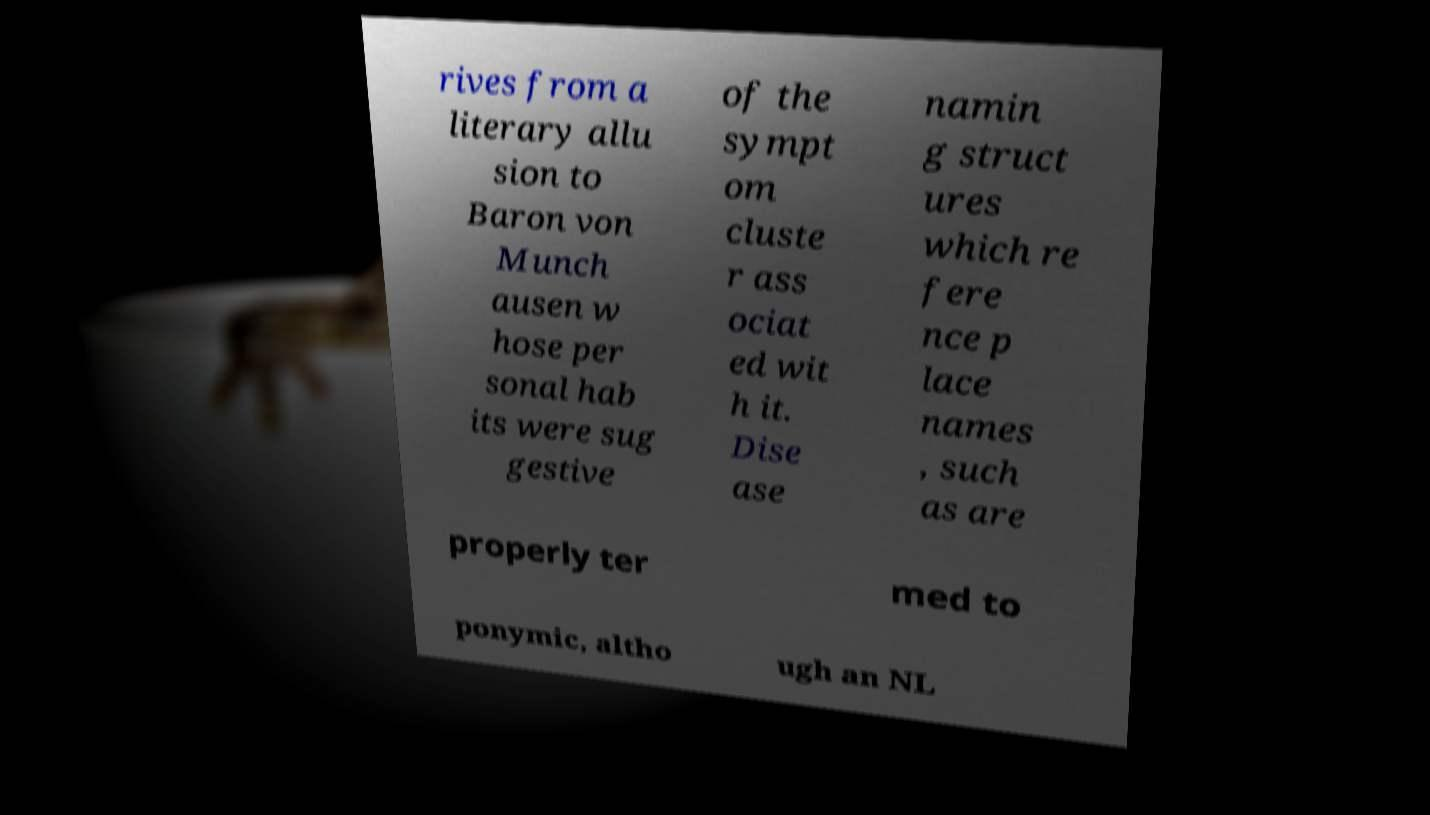Please identify and transcribe the text found in this image. rives from a literary allu sion to Baron von Munch ausen w hose per sonal hab its were sug gestive of the sympt om cluste r ass ociat ed wit h it. Dise ase namin g struct ures which re fere nce p lace names , such as are properly ter med to ponymic, altho ugh an NL 